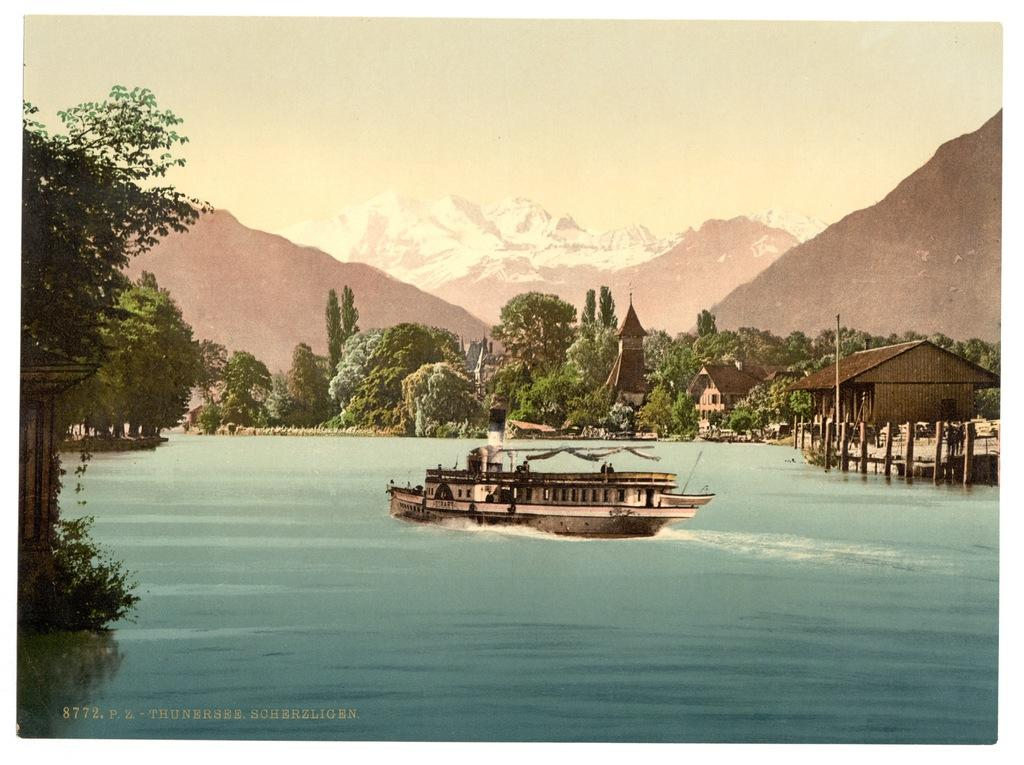What is happening to the water in the image? There is steam in the water in the image. What type of structures can be seen in the image? There are buildings visible in the image. What type of natural environment is visible in the background of the image? There are many trees and hills in the background of the image. What is visible at the top of the image? The sky is visible at the top of the image. How many cents are visible in the image? There are no cents present in the image. What type of tub is used to create the steam in the image? There is no tub present in the image; the steam is coming from the water. 